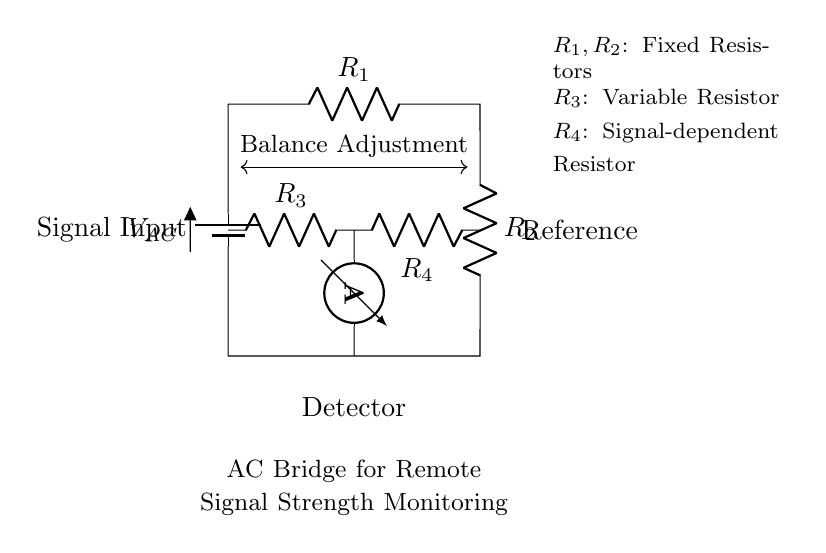What is the type of battery used in this circuit? The circuit diagram shows a battery labeled as V_AC, which indicates that it is an alternating current battery.
Answer: Alternating current What components are depicted on the left side of the circuit? The left side of the circuit contains a battery and the resistor R_1, indicating the input for voltage and current flow.
Answer: Battery and resistor What is the purpose of resistor R_3? Resistor R_3 is labeled as a variable resistor, which means it is used for adjusting resistance in the circuit, allowing balance adjustments.
Answer: Balance adjustment How many resistors are present in this AC bridge circuit? By counting, we can see that there are four resistors labeled R_1, R_2, R_3, and R_4 present in the circuit.
Answer: Four resistors What does the ammeter measure in this circuit? The ammeter is located toward the bottom of the circuit and is used for measuring current flow, which relates to the signal strength being monitored.
Answer: Current What does resistance R_4 depend on? R_4 is labeled as a signal-dependent resistor, meaning its resistance varies based on the input signal's characteristics.
Answer: Signal characteristics Which part of the circuit is designated for signal input? The signal input is indicated on the left side of the circuit near the labeled position, where the signal enters the circuit.
Answer: Left side 